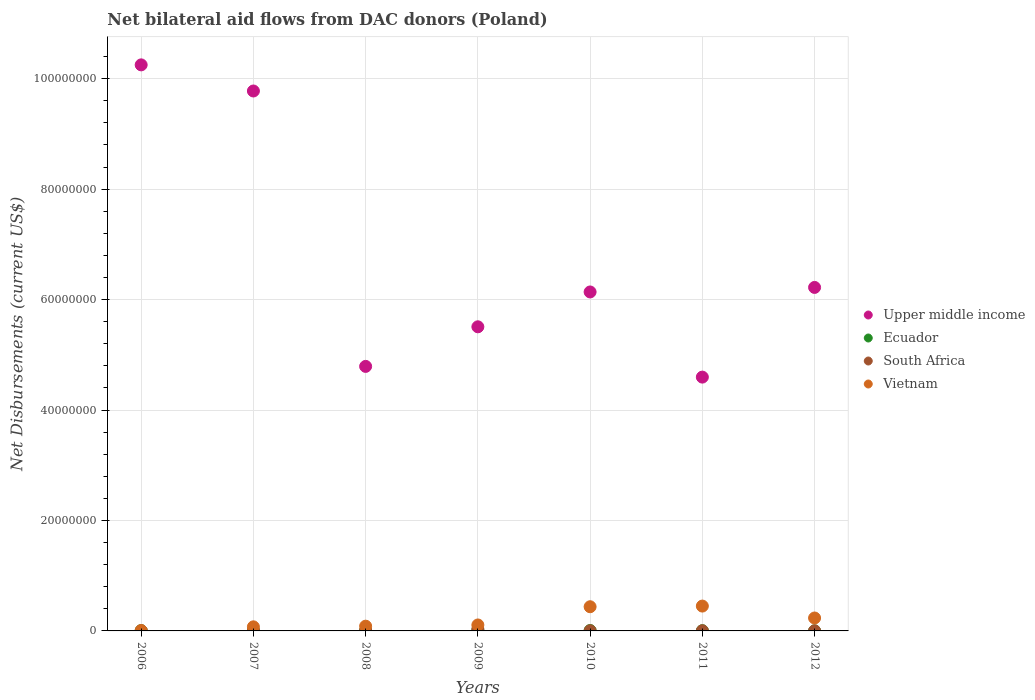How many different coloured dotlines are there?
Offer a terse response. 4. What is the net bilateral aid flows in South Africa in 2009?
Offer a terse response. 3.40e+05. Across all years, what is the minimum net bilateral aid flows in South Africa?
Ensure brevity in your answer.  10000. In which year was the net bilateral aid flows in South Africa maximum?
Make the answer very short. 2009. In which year was the net bilateral aid flows in Upper middle income minimum?
Your answer should be very brief. 2011. What is the total net bilateral aid flows in South Africa in the graph?
Provide a succinct answer. 6.00e+05. What is the difference between the net bilateral aid flows in Ecuador in 2007 and that in 2011?
Your answer should be compact. 4.00e+04. What is the difference between the net bilateral aid flows in South Africa in 2009 and the net bilateral aid flows in Ecuador in 2008?
Provide a succinct answer. 2.70e+05. What is the average net bilateral aid flows in South Africa per year?
Your answer should be very brief. 8.57e+04. In the year 2010, what is the difference between the net bilateral aid flows in South Africa and net bilateral aid flows in Ecuador?
Provide a succinct answer. -4.00e+04. What is the ratio of the net bilateral aid flows in Vietnam in 2007 to that in 2009?
Offer a terse response. 0.69. Is the net bilateral aid flows in Ecuador in 2008 less than that in 2009?
Ensure brevity in your answer.  Yes. Is the difference between the net bilateral aid flows in South Africa in 2008 and 2012 greater than the difference between the net bilateral aid flows in Ecuador in 2008 and 2012?
Give a very brief answer. Yes. What is the difference between the highest and the second highest net bilateral aid flows in Upper middle income?
Offer a terse response. 4.73e+06. What is the difference between the highest and the lowest net bilateral aid flows in Upper middle income?
Your answer should be very brief. 5.65e+07. Is the sum of the net bilateral aid flows in South Africa in 2007 and 2011 greater than the maximum net bilateral aid flows in Ecuador across all years?
Provide a succinct answer. No. Is it the case that in every year, the sum of the net bilateral aid flows in Vietnam and net bilateral aid flows in South Africa  is greater than the sum of net bilateral aid flows in Upper middle income and net bilateral aid flows in Ecuador?
Provide a succinct answer. No. Is the net bilateral aid flows in South Africa strictly greater than the net bilateral aid flows in Vietnam over the years?
Your answer should be compact. No. How many dotlines are there?
Offer a terse response. 4. How many years are there in the graph?
Make the answer very short. 7. Are the values on the major ticks of Y-axis written in scientific E-notation?
Keep it short and to the point. No. Does the graph contain any zero values?
Provide a succinct answer. No. Where does the legend appear in the graph?
Your answer should be very brief. Center right. How many legend labels are there?
Your response must be concise. 4. What is the title of the graph?
Provide a short and direct response. Net bilateral aid flows from DAC donors (Poland). Does "Palau" appear as one of the legend labels in the graph?
Make the answer very short. No. What is the label or title of the Y-axis?
Your answer should be compact. Net Disbursements (current US$). What is the Net Disbursements (current US$) in Upper middle income in 2006?
Offer a very short reply. 1.02e+08. What is the Net Disbursements (current US$) of South Africa in 2006?
Your answer should be very brief. 10000. What is the Net Disbursements (current US$) of Vietnam in 2006?
Keep it short and to the point. 6.00e+04. What is the Net Disbursements (current US$) of Upper middle income in 2007?
Offer a terse response. 9.78e+07. What is the Net Disbursements (current US$) of Ecuador in 2007?
Provide a succinct answer. 8.00e+04. What is the Net Disbursements (current US$) of Vietnam in 2007?
Provide a succinct answer. 7.40e+05. What is the Net Disbursements (current US$) in Upper middle income in 2008?
Your answer should be compact. 4.79e+07. What is the Net Disbursements (current US$) of South Africa in 2008?
Your answer should be very brief. 1.00e+05. What is the Net Disbursements (current US$) of Vietnam in 2008?
Keep it short and to the point. 8.60e+05. What is the Net Disbursements (current US$) of Upper middle income in 2009?
Your answer should be compact. 5.51e+07. What is the Net Disbursements (current US$) in Ecuador in 2009?
Your response must be concise. 1.20e+05. What is the Net Disbursements (current US$) of South Africa in 2009?
Offer a terse response. 3.40e+05. What is the Net Disbursements (current US$) of Vietnam in 2009?
Make the answer very short. 1.08e+06. What is the Net Disbursements (current US$) in Upper middle income in 2010?
Offer a terse response. 6.14e+07. What is the Net Disbursements (current US$) in Vietnam in 2010?
Keep it short and to the point. 4.38e+06. What is the Net Disbursements (current US$) of Upper middle income in 2011?
Keep it short and to the point. 4.60e+07. What is the Net Disbursements (current US$) in Ecuador in 2011?
Give a very brief answer. 4.00e+04. What is the Net Disbursements (current US$) of South Africa in 2011?
Ensure brevity in your answer.  3.00e+04. What is the Net Disbursements (current US$) in Vietnam in 2011?
Your response must be concise. 4.50e+06. What is the Net Disbursements (current US$) in Upper middle income in 2012?
Your response must be concise. 6.22e+07. What is the Net Disbursements (current US$) in Vietnam in 2012?
Your answer should be compact. 2.34e+06. Across all years, what is the maximum Net Disbursements (current US$) of Upper middle income?
Give a very brief answer. 1.02e+08. Across all years, what is the maximum Net Disbursements (current US$) of Ecuador?
Offer a very short reply. 1.20e+05. Across all years, what is the maximum Net Disbursements (current US$) of South Africa?
Your answer should be compact. 3.40e+05. Across all years, what is the maximum Net Disbursements (current US$) of Vietnam?
Your response must be concise. 4.50e+06. Across all years, what is the minimum Net Disbursements (current US$) in Upper middle income?
Keep it short and to the point. 4.60e+07. Across all years, what is the minimum Net Disbursements (current US$) in Ecuador?
Give a very brief answer. 10000. Across all years, what is the minimum Net Disbursements (current US$) in Vietnam?
Offer a terse response. 6.00e+04. What is the total Net Disbursements (current US$) in Upper middle income in the graph?
Make the answer very short. 4.73e+08. What is the total Net Disbursements (current US$) in South Africa in the graph?
Provide a short and direct response. 6.00e+05. What is the total Net Disbursements (current US$) in Vietnam in the graph?
Your answer should be very brief. 1.40e+07. What is the difference between the Net Disbursements (current US$) in Upper middle income in 2006 and that in 2007?
Your answer should be very brief. 4.73e+06. What is the difference between the Net Disbursements (current US$) of Vietnam in 2006 and that in 2007?
Offer a terse response. -6.80e+05. What is the difference between the Net Disbursements (current US$) of Upper middle income in 2006 and that in 2008?
Your response must be concise. 5.46e+07. What is the difference between the Net Disbursements (current US$) of Ecuador in 2006 and that in 2008?
Your response must be concise. -2.00e+04. What is the difference between the Net Disbursements (current US$) in Vietnam in 2006 and that in 2008?
Give a very brief answer. -8.00e+05. What is the difference between the Net Disbursements (current US$) in Upper middle income in 2006 and that in 2009?
Provide a short and direct response. 4.74e+07. What is the difference between the Net Disbursements (current US$) in Ecuador in 2006 and that in 2009?
Give a very brief answer. -7.00e+04. What is the difference between the Net Disbursements (current US$) in South Africa in 2006 and that in 2009?
Ensure brevity in your answer.  -3.30e+05. What is the difference between the Net Disbursements (current US$) in Vietnam in 2006 and that in 2009?
Provide a succinct answer. -1.02e+06. What is the difference between the Net Disbursements (current US$) in Upper middle income in 2006 and that in 2010?
Offer a very short reply. 4.11e+07. What is the difference between the Net Disbursements (current US$) of Ecuador in 2006 and that in 2010?
Ensure brevity in your answer.  -2.00e+04. What is the difference between the Net Disbursements (current US$) in Vietnam in 2006 and that in 2010?
Offer a terse response. -4.32e+06. What is the difference between the Net Disbursements (current US$) of Upper middle income in 2006 and that in 2011?
Your response must be concise. 5.65e+07. What is the difference between the Net Disbursements (current US$) in Ecuador in 2006 and that in 2011?
Offer a very short reply. 10000. What is the difference between the Net Disbursements (current US$) of South Africa in 2006 and that in 2011?
Your answer should be compact. -2.00e+04. What is the difference between the Net Disbursements (current US$) in Vietnam in 2006 and that in 2011?
Provide a succinct answer. -4.44e+06. What is the difference between the Net Disbursements (current US$) of Upper middle income in 2006 and that in 2012?
Your response must be concise. 4.03e+07. What is the difference between the Net Disbursements (current US$) in South Africa in 2006 and that in 2012?
Your answer should be very brief. -10000. What is the difference between the Net Disbursements (current US$) of Vietnam in 2006 and that in 2012?
Keep it short and to the point. -2.28e+06. What is the difference between the Net Disbursements (current US$) in Upper middle income in 2007 and that in 2008?
Make the answer very short. 4.99e+07. What is the difference between the Net Disbursements (current US$) in South Africa in 2007 and that in 2008?
Make the answer very short. -3.00e+04. What is the difference between the Net Disbursements (current US$) in Vietnam in 2007 and that in 2008?
Your answer should be very brief. -1.20e+05. What is the difference between the Net Disbursements (current US$) of Upper middle income in 2007 and that in 2009?
Provide a short and direct response. 4.27e+07. What is the difference between the Net Disbursements (current US$) of Ecuador in 2007 and that in 2009?
Ensure brevity in your answer.  -4.00e+04. What is the difference between the Net Disbursements (current US$) of South Africa in 2007 and that in 2009?
Provide a short and direct response. -2.70e+05. What is the difference between the Net Disbursements (current US$) of Upper middle income in 2007 and that in 2010?
Your answer should be very brief. 3.64e+07. What is the difference between the Net Disbursements (current US$) of South Africa in 2007 and that in 2010?
Provide a short and direct response. 4.00e+04. What is the difference between the Net Disbursements (current US$) in Vietnam in 2007 and that in 2010?
Keep it short and to the point. -3.64e+06. What is the difference between the Net Disbursements (current US$) of Upper middle income in 2007 and that in 2011?
Your answer should be compact. 5.18e+07. What is the difference between the Net Disbursements (current US$) of Ecuador in 2007 and that in 2011?
Your answer should be compact. 4.00e+04. What is the difference between the Net Disbursements (current US$) of Vietnam in 2007 and that in 2011?
Provide a short and direct response. -3.76e+06. What is the difference between the Net Disbursements (current US$) of Upper middle income in 2007 and that in 2012?
Your answer should be very brief. 3.56e+07. What is the difference between the Net Disbursements (current US$) of Ecuador in 2007 and that in 2012?
Make the answer very short. 7.00e+04. What is the difference between the Net Disbursements (current US$) of Vietnam in 2007 and that in 2012?
Provide a short and direct response. -1.60e+06. What is the difference between the Net Disbursements (current US$) of Upper middle income in 2008 and that in 2009?
Offer a terse response. -7.17e+06. What is the difference between the Net Disbursements (current US$) of South Africa in 2008 and that in 2009?
Your answer should be compact. -2.40e+05. What is the difference between the Net Disbursements (current US$) of Vietnam in 2008 and that in 2009?
Provide a succinct answer. -2.20e+05. What is the difference between the Net Disbursements (current US$) in Upper middle income in 2008 and that in 2010?
Give a very brief answer. -1.35e+07. What is the difference between the Net Disbursements (current US$) in Ecuador in 2008 and that in 2010?
Your response must be concise. 0. What is the difference between the Net Disbursements (current US$) in Vietnam in 2008 and that in 2010?
Give a very brief answer. -3.52e+06. What is the difference between the Net Disbursements (current US$) of Upper middle income in 2008 and that in 2011?
Your response must be concise. 1.94e+06. What is the difference between the Net Disbursements (current US$) of South Africa in 2008 and that in 2011?
Ensure brevity in your answer.  7.00e+04. What is the difference between the Net Disbursements (current US$) of Vietnam in 2008 and that in 2011?
Your answer should be compact. -3.64e+06. What is the difference between the Net Disbursements (current US$) in Upper middle income in 2008 and that in 2012?
Ensure brevity in your answer.  -1.43e+07. What is the difference between the Net Disbursements (current US$) in Vietnam in 2008 and that in 2012?
Give a very brief answer. -1.48e+06. What is the difference between the Net Disbursements (current US$) in Upper middle income in 2009 and that in 2010?
Provide a short and direct response. -6.31e+06. What is the difference between the Net Disbursements (current US$) of Ecuador in 2009 and that in 2010?
Offer a terse response. 5.00e+04. What is the difference between the Net Disbursements (current US$) in Vietnam in 2009 and that in 2010?
Offer a very short reply. -3.30e+06. What is the difference between the Net Disbursements (current US$) in Upper middle income in 2009 and that in 2011?
Offer a terse response. 9.11e+06. What is the difference between the Net Disbursements (current US$) in Vietnam in 2009 and that in 2011?
Make the answer very short. -3.42e+06. What is the difference between the Net Disbursements (current US$) of Upper middle income in 2009 and that in 2012?
Ensure brevity in your answer.  -7.13e+06. What is the difference between the Net Disbursements (current US$) of South Africa in 2009 and that in 2012?
Offer a terse response. 3.20e+05. What is the difference between the Net Disbursements (current US$) of Vietnam in 2009 and that in 2012?
Make the answer very short. -1.26e+06. What is the difference between the Net Disbursements (current US$) of Upper middle income in 2010 and that in 2011?
Offer a terse response. 1.54e+07. What is the difference between the Net Disbursements (current US$) in Ecuador in 2010 and that in 2011?
Give a very brief answer. 3.00e+04. What is the difference between the Net Disbursements (current US$) of South Africa in 2010 and that in 2011?
Offer a terse response. 0. What is the difference between the Net Disbursements (current US$) in Vietnam in 2010 and that in 2011?
Your response must be concise. -1.20e+05. What is the difference between the Net Disbursements (current US$) in Upper middle income in 2010 and that in 2012?
Give a very brief answer. -8.20e+05. What is the difference between the Net Disbursements (current US$) of Ecuador in 2010 and that in 2012?
Provide a short and direct response. 6.00e+04. What is the difference between the Net Disbursements (current US$) of Vietnam in 2010 and that in 2012?
Provide a succinct answer. 2.04e+06. What is the difference between the Net Disbursements (current US$) of Upper middle income in 2011 and that in 2012?
Your answer should be very brief. -1.62e+07. What is the difference between the Net Disbursements (current US$) in Ecuador in 2011 and that in 2012?
Your answer should be compact. 3.00e+04. What is the difference between the Net Disbursements (current US$) in Vietnam in 2011 and that in 2012?
Provide a short and direct response. 2.16e+06. What is the difference between the Net Disbursements (current US$) in Upper middle income in 2006 and the Net Disbursements (current US$) in Ecuador in 2007?
Offer a very short reply. 1.02e+08. What is the difference between the Net Disbursements (current US$) of Upper middle income in 2006 and the Net Disbursements (current US$) of South Africa in 2007?
Provide a succinct answer. 1.02e+08. What is the difference between the Net Disbursements (current US$) of Upper middle income in 2006 and the Net Disbursements (current US$) of Vietnam in 2007?
Ensure brevity in your answer.  1.02e+08. What is the difference between the Net Disbursements (current US$) of Ecuador in 2006 and the Net Disbursements (current US$) of South Africa in 2007?
Your answer should be very brief. -2.00e+04. What is the difference between the Net Disbursements (current US$) in Ecuador in 2006 and the Net Disbursements (current US$) in Vietnam in 2007?
Your response must be concise. -6.90e+05. What is the difference between the Net Disbursements (current US$) in South Africa in 2006 and the Net Disbursements (current US$) in Vietnam in 2007?
Your answer should be compact. -7.30e+05. What is the difference between the Net Disbursements (current US$) of Upper middle income in 2006 and the Net Disbursements (current US$) of Ecuador in 2008?
Ensure brevity in your answer.  1.02e+08. What is the difference between the Net Disbursements (current US$) in Upper middle income in 2006 and the Net Disbursements (current US$) in South Africa in 2008?
Your answer should be compact. 1.02e+08. What is the difference between the Net Disbursements (current US$) of Upper middle income in 2006 and the Net Disbursements (current US$) of Vietnam in 2008?
Make the answer very short. 1.02e+08. What is the difference between the Net Disbursements (current US$) of Ecuador in 2006 and the Net Disbursements (current US$) of Vietnam in 2008?
Make the answer very short. -8.10e+05. What is the difference between the Net Disbursements (current US$) of South Africa in 2006 and the Net Disbursements (current US$) of Vietnam in 2008?
Give a very brief answer. -8.50e+05. What is the difference between the Net Disbursements (current US$) in Upper middle income in 2006 and the Net Disbursements (current US$) in Ecuador in 2009?
Your answer should be compact. 1.02e+08. What is the difference between the Net Disbursements (current US$) in Upper middle income in 2006 and the Net Disbursements (current US$) in South Africa in 2009?
Your answer should be very brief. 1.02e+08. What is the difference between the Net Disbursements (current US$) of Upper middle income in 2006 and the Net Disbursements (current US$) of Vietnam in 2009?
Your answer should be very brief. 1.01e+08. What is the difference between the Net Disbursements (current US$) of Ecuador in 2006 and the Net Disbursements (current US$) of South Africa in 2009?
Offer a very short reply. -2.90e+05. What is the difference between the Net Disbursements (current US$) of Ecuador in 2006 and the Net Disbursements (current US$) of Vietnam in 2009?
Your answer should be very brief. -1.03e+06. What is the difference between the Net Disbursements (current US$) in South Africa in 2006 and the Net Disbursements (current US$) in Vietnam in 2009?
Offer a terse response. -1.07e+06. What is the difference between the Net Disbursements (current US$) in Upper middle income in 2006 and the Net Disbursements (current US$) in Ecuador in 2010?
Keep it short and to the point. 1.02e+08. What is the difference between the Net Disbursements (current US$) in Upper middle income in 2006 and the Net Disbursements (current US$) in South Africa in 2010?
Provide a succinct answer. 1.02e+08. What is the difference between the Net Disbursements (current US$) in Upper middle income in 2006 and the Net Disbursements (current US$) in Vietnam in 2010?
Your answer should be very brief. 9.81e+07. What is the difference between the Net Disbursements (current US$) in Ecuador in 2006 and the Net Disbursements (current US$) in Vietnam in 2010?
Provide a succinct answer. -4.33e+06. What is the difference between the Net Disbursements (current US$) of South Africa in 2006 and the Net Disbursements (current US$) of Vietnam in 2010?
Ensure brevity in your answer.  -4.37e+06. What is the difference between the Net Disbursements (current US$) of Upper middle income in 2006 and the Net Disbursements (current US$) of Ecuador in 2011?
Your answer should be very brief. 1.02e+08. What is the difference between the Net Disbursements (current US$) in Upper middle income in 2006 and the Net Disbursements (current US$) in South Africa in 2011?
Ensure brevity in your answer.  1.02e+08. What is the difference between the Net Disbursements (current US$) of Upper middle income in 2006 and the Net Disbursements (current US$) of Vietnam in 2011?
Keep it short and to the point. 9.80e+07. What is the difference between the Net Disbursements (current US$) in Ecuador in 2006 and the Net Disbursements (current US$) in Vietnam in 2011?
Your answer should be compact. -4.45e+06. What is the difference between the Net Disbursements (current US$) in South Africa in 2006 and the Net Disbursements (current US$) in Vietnam in 2011?
Keep it short and to the point. -4.49e+06. What is the difference between the Net Disbursements (current US$) of Upper middle income in 2006 and the Net Disbursements (current US$) of Ecuador in 2012?
Offer a very short reply. 1.02e+08. What is the difference between the Net Disbursements (current US$) of Upper middle income in 2006 and the Net Disbursements (current US$) of South Africa in 2012?
Make the answer very short. 1.02e+08. What is the difference between the Net Disbursements (current US$) of Upper middle income in 2006 and the Net Disbursements (current US$) of Vietnam in 2012?
Give a very brief answer. 1.00e+08. What is the difference between the Net Disbursements (current US$) in Ecuador in 2006 and the Net Disbursements (current US$) in Vietnam in 2012?
Give a very brief answer. -2.29e+06. What is the difference between the Net Disbursements (current US$) in South Africa in 2006 and the Net Disbursements (current US$) in Vietnam in 2012?
Ensure brevity in your answer.  -2.33e+06. What is the difference between the Net Disbursements (current US$) in Upper middle income in 2007 and the Net Disbursements (current US$) in Ecuador in 2008?
Provide a short and direct response. 9.77e+07. What is the difference between the Net Disbursements (current US$) in Upper middle income in 2007 and the Net Disbursements (current US$) in South Africa in 2008?
Keep it short and to the point. 9.77e+07. What is the difference between the Net Disbursements (current US$) in Upper middle income in 2007 and the Net Disbursements (current US$) in Vietnam in 2008?
Your response must be concise. 9.69e+07. What is the difference between the Net Disbursements (current US$) of Ecuador in 2007 and the Net Disbursements (current US$) of South Africa in 2008?
Your answer should be very brief. -2.00e+04. What is the difference between the Net Disbursements (current US$) of Ecuador in 2007 and the Net Disbursements (current US$) of Vietnam in 2008?
Offer a very short reply. -7.80e+05. What is the difference between the Net Disbursements (current US$) of South Africa in 2007 and the Net Disbursements (current US$) of Vietnam in 2008?
Make the answer very short. -7.90e+05. What is the difference between the Net Disbursements (current US$) of Upper middle income in 2007 and the Net Disbursements (current US$) of Ecuador in 2009?
Ensure brevity in your answer.  9.76e+07. What is the difference between the Net Disbursements (current US$) in Upper middle income in 2007 and the Net Disbursements (current US$) in South Africa in 2009?
Provide a succinct answer. 9.74e+07. What is the difference between the Net Disbursements (current US$) in Upper middle income in 2007 and the Net Disbursements (current US$) in Vietnam in 2009?
Your response must be concise. 9.67e+07. What is the difference between the Net Disbursements (current US$) in South Africa in 2007 and the Net Disbursements (current US$) in Vietnam in 2009?
Provide a succinct answer. -1.01e+06. What is the difference between the Net Disbursements (current US$) of Upper middle income in 2007 and the Net Disbursements (current US$) of Ecuador in 2010?
Keep it short and to the point. 9.77e+07. What is the difference between the Net Disbursements (current US$) of Upper middle income in 2007 and the Net Disbursements (current US$) of South Africa in 2010?
Provide a succinct answer. 9.77e+07. What is the difference between the Net Disbursements (current US$) in Upper middle income in 2007 and the Net Disbursements (current US$) in Vietnam in 2010?
Make the answer very short. 9.34e+07. What is the difference between the Net Disbursements (current US$) of Ecuador in 2007 and the Net Disbursements (current US$) of Vietnam in 2010?
Give a very brief answer. -4.30e+06. What is the difference between the Net Disbursements (current US$) of South Africa in 2007 and the Net Disbursements (current US$) of Vietnam in 2010?
Make the answer very short. -4.31e+06. What is the difference between the Net Disbursements (current US$) of Upper middle income in 2007 and the Net Disbursements (current US$) of Ecuador in 2011?
Make the answer very short. 9.77e+07. What is the difference between the Net Disbursements (current US$) in Upper middle income in 2007 and the Net Disbursements (current US$) in South Africa in 2011?
Ensure brevity in your answer.  9.77e+07. What is the difference between the Net Disbursements (current US$) in Upper middle income in 2007 and the Net Disbursements (current US$) in Vietnam in 2011?
Provide a short and direct response. 9.33e+07. What is the difference between the Net Disbursements (current US$) in Ecuador in 2007 and the Net Disbursements (current US$) in Vietnam in 2011?
Offer a terse response. -4.42e+06. What is the difference between the Net Disbursements (current US$) in South Africa in 2007 and the Net Disbursements (current US$) in Vietnam in 2011?
Provide a succinct answer. -4.43e+06. What is the difference between the Net Disbursements (current US$) of Upper middle income in 2007 and the Net Disbursements (current US$) of Ecuador in 2012?
Provide a short and direct response. 9.78e+07. What is the difference between the Net Disbursements (current US$) in Upper middle income in 2007 and the Net Disbursements (current US$) in South Africa in 2012?
Keep it short and to the point. 9.78e+07. What is the difference between the Net Disbursements (current US$) in Upper middle income in 2007 and the Net Disbursements (current US$) in Vietnam in 2012?
Your response must be concise. 9.54e+07. What is the difference between the Net Disbursements (current US$) in Ecuador in 2007 and the Net Disbursements (current US$) in Vietnam in 2012?
Offer a very short reply. -2.26e+06. What is the difference between the Net Disbursements (current US$) of South Africa in 2007 and the Net Disbursements (current US$) of Vietnam in 2012?
Offer a very short reply. -2.27e+06. What is the difference between the Net Disbursements (current US$) of Upper middle income in 2008 and the Net Disbursements (current US$) of Ecuador in 2009?
Your answer should be compact. 4.78e+07. What is the difference between the Net Disbursements (current US$) of Upper middle income in 2008 and the Net Disbursements (current US$) of South Africa in 2009?
Offer a very short reply. 4.76e+07. What is the difference between the Net Disbursements (current US$) in Upper middle income in 2008 and the Net Disbursements (current US$) in Vietnam in 2009?
Ensure brevity in your answer.  4.68e+07. What is the difference between the Net Disbursements (current US$) of Ecuador in 2008 and the Net Disbursements (current US$) of Vietnam in 2009?
Provide a succinct answer. -1.01e+06. What is the difference between the Net Disbursements (current US$) in South Africa in 2008 and the Net Disbursements (current US$) in Vietnam in 2009?
Offer a very short reply. -9.80e+05. What is the difference between the Net Disbursements (current US$) in Upper middle income in 2008 and the Net Disbursements (current US$) in Ecuador in 2010?
Offer a very short reply. 4.78e+07. What is the difference between the Net Disbursements (current US$) of Upper middle income in 2008 and the Net Disbursements (current US$) of South Africa in 2010?
Keep it short and to the point. 4.79e+07. What is the difference between the Net Disbursements (current US$) in Upper middle income in 2008 and the Net Disbursements (current US$) in Vietnam in 2010?
Make the answer very short. 4.35e+07. What is the difference between the Net Disbursements (current US$) in Ecuador in 2008 and the Net Disbursements (current US$) in Vietnam in 2010?
Give a very brief answer. -4.31e+06. What is the difference between the Net Disbursements (current US$) of South Africa in 2008 and the Net Disbursements (current US$) of Vietnam in 2010?
Offer a terse response. -4.28e+06. What is the difference between the Net Disbursements (current US$) in Upper middle income in 2008 and the Net Disbursements (current US$) in Ecuador in 2011?
Provide a short and direct response. 4.79e+07. What is the difference between the Net Disbursements (current US$) in Upper middle income in 2008 and the Net Disbursements (current US$) in South Africa in 2011?
Your answer should be compact. 4.79e+07. What is the difference between the Net Disbursements (current US$) of Upper middle income in 2008 and the Net Disbursements (current US$) of Vietnam in 2011?
Provide a short and direct response. 4.34e+07. What is the difference between the Net Disbursements (current US$) in Ecuador in 2008 and the Net Disbursements (current US$) in South Africa in 2011?
Ensure brevity in your answer.  4.00e+04. What is the difference between the Net Disbursements (current US$) in Ecuador in 2008 and the Net Disbursements (current US$) in Vietnam in 2011?
Provide a succinct answer. -4.43e+06. What is the difference between the Net Disbursements (current US$) in South Africa in 2008 and the Net Disbursements (current US$) in Vietnam in 2011?
Offer a terse response. -4.40e+06. What is the difference between the Net Disbursements (current US$) of Upper middle income in 2008 and the Net Disbursements (current US$) of Ecuador in 2012?
Provide a short and direct response. 4.79e+07. What is the difference between the Net Disbursements (current US$) in Upper middle income in 2008 and the Net Disbursements (current US$) in South Africa in 2012?
Offer a very short reply. 4.79e+07. What is the difference between the Net Disbursements (current US$) of Upper middle income in 2008 and the Net Disbursements (current US$) of Vietnam in 2012?
Your response must be concise. 4.56e+07. What is the difference between the Net Disbursements (current US$) of Ecuador in 2008 and the Net Disbursements (current US$) of South Africa in 2012?
Your answer should be compact. 5.00e+04. What is the difference between the Net Disbursements (current US$) in Ecuador in 2008 and the Net Disbursements (current US$) in Vietnam in 2012?
Give a very brief answer. -2.27e+06. What is the difference between the Net Disbursements (current US$) in South Africa in 2008 and the Net Disbursements (current US$) in Vietnam in 2012?
Keep it short and to the point. -2.24e+06. What is the difference between the Net Disbursements (current US$) in Upper middle income in 2009 and the Net Disbursements (current US$) in Ecuador in 2010?
Offer a terse response. 5.50e+07. What is the difference between the Net Disbursements (current US$) in Upper middle income in 2009 and the Net Disbursements (current US$) in South Africa in 2010?
Offer a very short reply. 5.50e+07. What is the difference between the Net Disbursements (current US$) in Upper middle income in 2009 and the Net Disbursements (current US$) in Vietnam in 2010?
Offer a terse response. 5.07e+07. What is the difference between the Net Disbursements (current US$) of Ecuador in 2009 and the Net Disbursements (current US$) of Vietnam in 2010?
Provide a short and direct response. -4.26e+06. What is the difference between the Net Disbursements (current US$) of South Africa in 2009 and the Net Disbursements (current US$) of Vietnam in 2010?
Your response must be concise. -4.04e+06. What is the difference between the Net Disbursements (current US$) in Upper middle income in 2009 and the Net Disbursements (current US$) in Ecuador in 2011?
Offer a terse response. 5.50e+07. What is the difference between the Net Disbursements (current US$) of Upper middle income in 2009 and the Net Disbursements (current US$) of South Africa in 2011?
Your response must be concise. 5.50e+07. What is the difference between the Net Disbursements (current US$) of Upper middle income in 2009 and the Net Disbursements (current US$) of Vietnam in 2011?
Your answer should be compact. 5.06e+07. What is the difference between the Net Disbursements (current US$) of Ecuador in 2009 and the Net Disbursements (current US$) of Vietnam in 2011?
Your answer should be very brief. -4.38e+06. What is the difference between the Net Disbursements (current US$) of South Africa in 2009 and the Net Disbursements (current US$) of Vietnam in 2011?
Offer a terse response. -4.16e+06. What is the difference between the Net Disbursements (current US$) of Upper middle income in 2009 and the Net Disbursements (current US$) of Ecuador in 2012?
Provide a short and direct response. 5.51e+07. What is the difference between the Net Disbursements (current US$) in Upper middle income in 2009 and the Net Disbursements (current US$) in South Africa in 2012?
Offer a terse response. 5.50e+07. What is the difference between the Net Disbursements (current US$) of Upper middle income in 2009 and the Net Disbursements (current US$) of Vietnam in 2012?
Give a very brief answer. 5.27e+07. What is the difference between the Net Disbursements (current US$) of Ecuador in 2009 and the Net Disbursements (current US$) of Vietnam in 2012?
Keep it short and to the point. -2.22e+06. What is the difference between the Net Disbursements (current US$) in South Africa in 2009 and the Net Disbursements (current US$) in Vietnam in 2012?
Offer a very short reply. -2.00e+06. What is the difference between the Net Disbursements (current US$) in Upper middle income in 2010 and the Net Disbursements (current US$) in Ecuador in 2011?
Your answer should be compact. 6.13e+07. What is the difference between the Net Disbursements (current US$) in Upper middle income in 2010 and the Net Disbursements (current US$) in South Africa in 2011?
Keep it short and to the point. 6.14e+07. What is the difference between the Net Disbursements (current US$) of Upper middle income in 2010 and the Net Disbursements (current US$) of Vietnam in 2011?
Keep it short and to the point. 5.69e+07. What is the difference between the Net Disbursements (current US$) of Ecuador in 2010 and the Net Disbursements (current US$) of Vietnam in 2011?
Provide a short and direct response. -4.43e+06. What is the difference between the Net Disbursements (current US$) in South Africa in 2010 and the Net Disbursements (current US$) in Vietnam in 2011?
Give a very brief answer. -4.47e+06. What is the difference between the Net Disbursements (current US$) of Upper middle income in 2010 and the Net Disbursements (current US$) of Ecuador in 2012?
Make the answer very short. 6.14e+07. What is the difference between the Net Disbursements (current US$) of Upper middle income in 2010 and the Net Disbursements (current US$) of South Africa in 2012?
Offer a very short reply. 6.14e+07. What is the difference between the Net Disbursements (current US$) of Upper middle income in 2010 and the Net Disbursements (current US$) of Vietnam in 2012?
Ensure brevity in your answer.  5.90e+07. What is the difference between the Net Disbursements (current US$) of Ecuador in 2010 and the Net Disbursements (current US$) of South Africa in 2012?
Your response must be concise. 5.00e+04. What is the difference between the Net Disbursements (current US$) in Ecuador in 2010 and the Net Disbursements (current US$) in Vietnam in 2012?
Keep it short and to the point. -2.27e+06. What is the difference between the Net Disbursements (current US$) of South Africa in 2010 and the Net Disbursements (current US$) of Vietnam in 2012?
Your response must be concise. -2.31e+06. What is the difference between the Net Disbursements (current US$) in Upper middle income in 2011 and the Net Disbursements (current US$) in Ecuador in 2012?
Your answer should be very brief. 4.60e+07. What is the difference between the Net Disbursements (current US$) of Upper middle income in 2011 and the Net Disbursements (current US$) of South Africa in 2012?
Your answer should be very brief. 4.59e+07. What is the difference between the Net Disbursements (current US$) in Upper middle income in 2011 and the Net Disbursements (current US$) in Vietnam in 2012?
Ensure brevity in your answer.  4.36e+07. What is the difference between the Net Disbursements (current US$) in Ecuador in 2011 and the Net Disbursements (current US$) in Vietnam in 2012?
Your answer should be very brief. -2.30e+06. What is the difference between the Net Disbursements (current US$) in South Africa in 2011 and the Net Disbursements (current US$) in Vietnam in 2012?
Ensure brevity in your answer.  -2.31e+06. What is the average Net Disbursements (current US$) of Upper middle income per year?
Offer a terse response. 6.75e+07. What is the average Net Disbursements (current US$) of Ecuador per year?
Offer a very short reply. 6.29e+04. What is the average Net Disbursements (current US$) of South Africa per year?
Make the answer very short. 8.57e+04. What is the average Net Disbursements (current US$) in Vietnam per year?
Ensure brevity in your answer.  1.99e+06. In the year 2006, what is the difference between the Net Disbursements (current US$) of Upper middle income and Net Disbursements (current US$) of Ecuador?
Provide a succinct answer. 1.02e+08. In the year 2006, what is the difference between the Net Disbursements (current US$) in Upper middle income and Net Disbursements (current US$) in South Africa?
Your answer should be very brief. 1.02e+08. In the year 2006, what is the difference between the Net Disbursements (current US$) of Upper middle income and Net Disbursements (current US$) of Vietnam?
Offer a very short reply. 1.02e+08. In the year 2006, what is the difference between the Net Disbursements (current US$) in Ecuador and Net Disbursements (current US$) in Vietnam?
Keep it short and to the point. -10000. In the year 2006, what is the difference between the Net Disbursements (current US$) of South Africa and Net Disbursements (current US$) of Vietnam?
Provide a succinct answer. -5.00e+04. In the year 2007, what is the difference between the Net Disbursements (current US$) in Upper middle income and Net Disbursements (current US$) in Ecuador?
Ensure brevity in your answer.  9.77e+07. In the year 2007, what is the difference between the Net Disbursements (current US$) of Upper middle income and Net Disbursements (current US$) of South Africa?
Your answer should be very brief. 9.77e+07. In the year 2007, what is the difference between the Net Disbursements (current US$) of Upper middle income and Net Disbursements (current US$) of Vietnam?
Give a very brief answer. 9.70e+07. In the year 2007, what is the difference between the Net Disbursements (current US$) in Ecuador and Net Disbursements (current US$) in Vietnam?
Provide a short and direct response. -6.60e+05. In the year 2007, what is the difference between the Net Disbursements (current US$) in South Africa and Net Disbursements (current US$) in Vietnam?
Make the answer very short. -6.70e+05. In the year 2008, what is the difference between the Net Disbursements (current US$) in Upper middle income and Net Disbursements (current US$) in Ecuador?
Provide a succinct answer. 4.78e+07. In the year 2008, what is the difference between the Net Disbursements (current US$) in Upper middle income and Net Disbursements (current US$) in South Africa?
Offer a very short reply. 4.78e+07. In the year 2008, what is the difference between the Net Disbursements (current US$) of Upper middle income and Net Disbursements (current US$) of Vietnam?
Keep it short and to the point. 4.70e+07. In the year 2008, what is the difference between the Net Disbursements (current US$) in Ecuador and Net Disbursements (current US$) in Vietnam?
Give a very brief answer. -7.90e+05. In the year 2008, what is the difference between the Net Disbursements (current US$) in South Africa and Net Disbursements (current US$) in Vietnam?
Ensure brevity in your answer.  -7.60e+05. In the year 2009, what is the difference between the Net Disbursements (current US$) in Upper middle income and Net Disbursements (current US$) in Ecuador?
Ensure brevity in your answer.  5.50e+07. In the year 2009, what is the difference between the Net Disbursements (current US$) of Upper middle income and Net Disbursements (current US$) of South Africa?
Make the answer very short. 5.47e+07. In the year 2009, what is the difference between the Net Disbursements (current US$) of Upper middle income and Net Disbursements (current US$) of Vietnam?
Offer a very short reply. 5.40e+07. In the year 2009, what is the difference between the Net Disbursements (current US$) in Ecuador and Net Disbursements (current US$) in South Africa?
Make the answer very short. -2.20e+05. In the year 2009, what is the difference between the Net Disbursements (current US$) of Ecuador and Net Disbursements (current US$) of Vietnam?
Give a very brief answer. -9.60e+05. In the year 2009, what is the difference between the Net Disbursements (current US$) in South Africa and Net Disbursements (current US$) in Vietnam?
Provide a short and direct response. -7.40e+05. In the year 2010, what is the difference between the Net Disbursements (current US$) of Upper middle income and Net Disbursements (current US$) of Ecuador?
Your response must be concise. 6.13e+07. In the year 2010, what is the difference between the Net Disbursements (current US$) of Upper middle income and Net Disbursements (current US$) of South Africa?
Offer a terse response. 6.14e+07. In the year 2010, what is the difference between the Net Disbursements (current US$) of Upper middle income and Net Disbursements (current US$) of Vietnam?
Offer a terse response. 5.70e+07. In the year 2010, what is the difference between the Net Disbursements (current US$) of Ecuador and Net Disbursements (current US$) of South Africa?
Your answer should be very brief. 4.00e+04. In the year 2010, what is the difference between the Net Disbursements (current US$) of Ecuador and Net Disbursements (current US$) of Vietnam?
Your answer should be compact. -4.31e+06. In the year 2010, what is the difference between the Net Disbursements (current US$) in South Africa and Net Disbursements (current US$) in Vietnam?
Keep it short and to the point. -4.35e+06. In the year 2011, what is the difference between the Net Disbursements (current US$) of Upper middle income and Net Disbursements (current US$) of Ecuador?
Ensure brevity in your answer.  4.59e+07. In the year 2011, what is the difference between the Net Disbursements (current US$) of Upper middle income and Net Disbursements (current US$) of South Africa?
Make the answer very short. 4.59e+07. In the year 2011, what is the difference between the Net Disbursements (current US$) of Upper middle income and Net Disbursements (current US$) of Vietnam?
Ensure brevity in your answer.  4.15e+07. In the year 2011, what is the difference between the Net Disbursements (current US$) in Ecuador and Net Disbursements (current US$) in South Africa?
Offer a very short reply. 10000. In the year 2011, what is the difference between the Net Disbursements (current US$) of Ecuador and Net Disbursements (current US$) of Vietnam?
Ensure brevity in your answer.  -4.46e+06. In the year 2011, what is the difference between the Net Disbursements (current US$) in South Africa and Net Disbursements (current US$) in Vietnam?
Your response must be concise. -4.47e+06. In the year 2012, what is the difference between the Net Disbursements (current US$) of Upper middle income and Net Disbursements (current US$) of Ecuador?
Your response must be concise. 6.22e+07. In the year 2012, what is the difference between the Net Disbursements (current US$) in Upper middle income and Net Disbursements (current US$) in South Africa?
Provide a succinct answer. 6.22e+07. In the year 2012, what is the difference between the Net Disbursements (current US$) of Upper middle income and Net Disbursements (current US$) of Vietnam?
Make the answer very short. 5.99e+07. In the year 2012, what is the difference between the Net Disbursements (current US$) in Ecuador and Net Disbursements (current US$) in Vietnam?
Offer a very short reply. -2.33e+06. In the year 2012, what is the difference between the Net Disbursements (current US$) of South Africa and Net Disbursements (current US$) of Vietnam?
Give a very brief answer. -2.32e+06. What is the ratio of the Net Disbursements (current US$) of Upper middle income in 2006 to that in 2007?
Ensure brevity in your answer.  1.05. What is the ratio of the Net Disbursements (current US$) in South Africa in 2006 to that in 2007?
Keep it short and to the point. 0.14. What is the ratio of the Net Disbursements (current US$) of Vietnam in 2006 to that in 2007?
Your answer should be compact. 0.08. What is the ratio of the Net Disbursements (current US$) in Upper middle income in 2006 to that in 2008?
Give a very brief answer. 2.14. What is the ratio of the Net Disbursements (current US$) in South Africa in 2006 to that in 2008?
Keep it short and to the point. 0.1. What is the ratio of the Net Disbursements (current US$) in Vietnam in 2006 to that in 2008?
Offer a terse response. 0.07. What is the ratio of the Net Disbursements (current US$) in Upper middle income in 2006 to that in 2009?
Your answer should be compact. 1.86. What is the ratio of the Net Disbursements (current US$) in Ecuador in 2006 to that in 2009?
Keep it short and to the point. 0.42. What is the ratio of the Net Disbursements (current US$) of South Africa in 2006 to that in 2009?
Offer a very short reply. 0.03. What is the ratio of the Net Disbursements (current US$) in Vietnam in 2006 to that in 2009?
Ensure brevity in your answer.  0.06. What is the ratio of the Net Disbursements (current US$) of Upper middle income in 2006 to that in 2010?
Offer a very short reply. 1.67. What is the ratio of the Net Disbursements (current US$) in South Africa in 2006 to that in 2010?
Keep it short and to the point. 0.33. What is the ratio of the Net Disbursements (current US$) in Vietnam in 2006 to that in 2010?
Provide a short and direct response. 0.01. What is the ratio of the Net Disbursements (current US$) of Upper middle income in 2006 to that in 2011?
Keep it short and to the point. 2.23. What is the ratio of the Net Disbursements (current US$) of Vietnam in 2006 to that in 2011?
Your answer should be very brief. 0.01. What is the ratio of the Net Disbursements (current US$) of Upper middle income in 2006 to that in 2012?
Your answer should be compact. 1.65. What is the ratio of the Net Disbursements (current US$) of Ecuador in 2006 to that in 2012?
Offer a terse response. 5. What is the ratio of the Net Disbursements (current US$) in South Africa in 2006 to that in 2012?
Give a very brief answer. 0.5. What is the ratio of the Net Disbursements (current US$) of Vietnam in 2006 to that in 2012?
Provide a succinct answer. 0.03. What is the ratio of the Net Disbursements (current US$) in Upper middle income in 2007 to that in 2008?
Your response must be concise. 2.04. What is the ratio of the Net Disbursements (current US$) of Vietnam in 2007 to that in 2008?
Give a very brief answer. 0.86. What is the ratio of the Net Disbursements (current US$) in Upper middle income in 2007 to that in 2009?
Offer a terse response. 1.78. What is the ratio of the Net Disbursements (current US$) in South Africa in 2007 to that in 2009?
Give a very brief answer. 0.21. What is the ratio of the Net Disbursements (current US$) in Vietnam in 2007 to that in 2009?
Offer a terse response. 0.69. What is the ratio of the Net Disbursements (current US$) in Upper middle income in 2007 to that in 2010?
Ensure brevity in your answer.  1.59. What is the ratio of the Net Disbursements (current US$) in South Africa in 2007 to that in 2010?
Ensure brevity in your answer.  2.33. What is the ratio of the Net Disbursements (current US$) of Vietnam in 2007 to that in 2010?
Your answer should be compact. 0.17. What is the ratio of the Net Disbursements (current US$) in Upper middle income in 2007 to that in 2011?
Provide a succinct answer. 2.13. What is the ratio of the Net Disbursements (current US$) of South Africa in 2007 to that in 2011?
Make the answer very short. 2.33. What is the ratio of the Net Disbursements (current US$) of Vietnam in 2007 to that in 2011?
Make the answer very short. 0.16. What is the ratio of the Net Disbursements (current US$) in Upper middle income in 2007 to that in 2012?
Provide a succinct answer. 1.57. What is the ratio of the Net Disbursements (current US$) in Ecuador in 2007 to that in 2012?
Ensure brevity in your answer.  8. What is the ratio of the Net Disbursements (current US$) in South Africa in 2007 to that in 2012?
Your answer should be compact. 3.5. What is the ratio of the Net Disbursements (current US$) of Vietnam in 2007 to that in 2012?
Make the answer very short. 0.32. What is the ratio of the Net Disbursements (current US$) in Upper middle income in 2008 to that in 2009?
Make the answer very short. 0.87. What is the ratio of the Net Disbursements (current US$) of Ecuador in 2008 to that in 2009?
Offer a terse response. 0.58. What is the ratio of the Net Disbursements (current US$) of South Africa in 2008 to that in 2009?
Provide a succinct answer. 0.29. What is the ratio of the Net Disbursements (current US$) in Vietnam in 2008 to that in 2009?
Make the answer very short. 0.8. What is the ratio of the Net Disbursements (current US$) in Upper middle income in 2008 to that in 2010?
Offer a terse response. 0.78. What is the ratio of the Net Disbursements (current US$) in Ecuador in 2008 to that in 2010?
Your answer should be very brief. 1. What is the ratio of the Net Disbursements (current US$) of South Africa in 2008 to that in 2010?
Give a very brief answer. 3.33. What is the ratio of the Net Disbursements (current US$) of Vietnam in 2008 to that in 2010?
Ensure brevity in your answer.  0.2. What is the ratio of the Net Disbursements (current US$) in Upper middle income in 2008 to that in 2011?
Keep it short and to the point. 1.04. What is the ratio of the Net Disbursements (current US$) of Ecuador in 2008 to that in 2011?
Your answer should be compact. 1.75. What is the ratio of the Net Disbursements (current US$) in Vietnam in 2008 to that in 2011?
Your answer should be very brief. 0.19. What is the ratio of the Net Disbursements (current US$) of Upper middle income in 2008 to that in 2012?
Keep it short and to the point. 0.77. What is the ratio of the Net Disbursements (current US$) in Ecuador in 2008 to that in 2012?
Your response must be concise. 7. What is the ratio of the Net Disbursements (current US$) in South Africa in 2008 to that in 2012?
Your response must be concise. 5. What is the ratio of the Net Disbursements (current US$) of Vietnam in 2008 to that in 2012?
Provide a succinct answer. 0.37. What is the ratio of the Net Disbursements (current US$) of Upper middle income in 2009 to that in 2010?
Provide a short and direct response. 0.9. What is the ratio of the Net Disbursements (current US$) of Ecuador in 2009 to that in 2010?
Give a very brief answer. 1.71. What is the ratio of the Net Disbursements (current US$) in South Africa in 2009 to that in 2010?
Give a very brief answer. 11.33. What is the ratio of the Net Disbursements (current US$) of Vietnam in 2009 to that in 2010?
Your response must be concise. 0.25. What is the ratio of the Net Disbursements (current US$) in Upper middle income in 2009 to that in 2011?
Your response must be concise. 1.2. What is the ratio of the Net Disbursements (current US$) in South Africa in 2009 to that in 2011?
Your answer should be very brief. 11.33. What is the ratio of the Net Disbursements (current US$) in Vietnam in 2009 to that in 2011?
Provide a short and direct response. 0.24. What is the ratio of the Net Disbursements (current US$) of Upper middle income in 2009 to that in 2012?
Your answer should be compact. 0.89. What is the ratio of the Net Disbursements (current US$) of Ecuador in 2009 to that in 2012?
Your answer should be very brief. 12. What is the ratio of the Net Disbursements (current US$) in Vietnam in 2009 to that in 2012?
Keep it short and to the point. 0.46. What is the ratio of the Net Disbursements (current US$) of Upper middle income in 2010 to that in 2011?
Provide a short and direct response. 1.34. What is the ratio of the Net Disbursements (current US$) in Ecuador in 2010 to that in 2011?
Make the answer very short. 1.75. What is the ratio of the Net Disbursements (current US$) in Vietnam in 2010 to that in 2011?
Make the answer very short. 0.97. What is the ratio of the Net Disbursements (current US$) of Vietnam in 2010 to that in 2012?
Make the answer very short. 1.87. What is the ratio of the Net Disbursements (current US$) of Upper middle income in 2011 to that in 2012?
Give a very brief answer. 0.74. What is the ratio of the Net Disbursements (current US$) in South Africa in 2011 to that in 2012?
Your response must be concise. 1.5. What is the ratio of the Net Disbursements (current US$) of Vietnam in 2011 to that in 2012?
Offer a terse response. 1.92. What is the difference between the highest and the second highest Net Disbursements (current US$) of Upper middle income?
Your answer should be very brief. 4.73e+06. What is the difference between the highest and the second highest Net Disbursements (current US$) of South Africa?
Your answer should be compact. 2.40e+05. What is the difference between the highest and the lowest Net Disbursements (current US$) in Upper middle income?
Make the answer very short. 5.65e+07. What is the difference between the highest and the lowest Net Disbursements (current US$) of Vietnam?
Make the answer very short. 4.44e+06. 